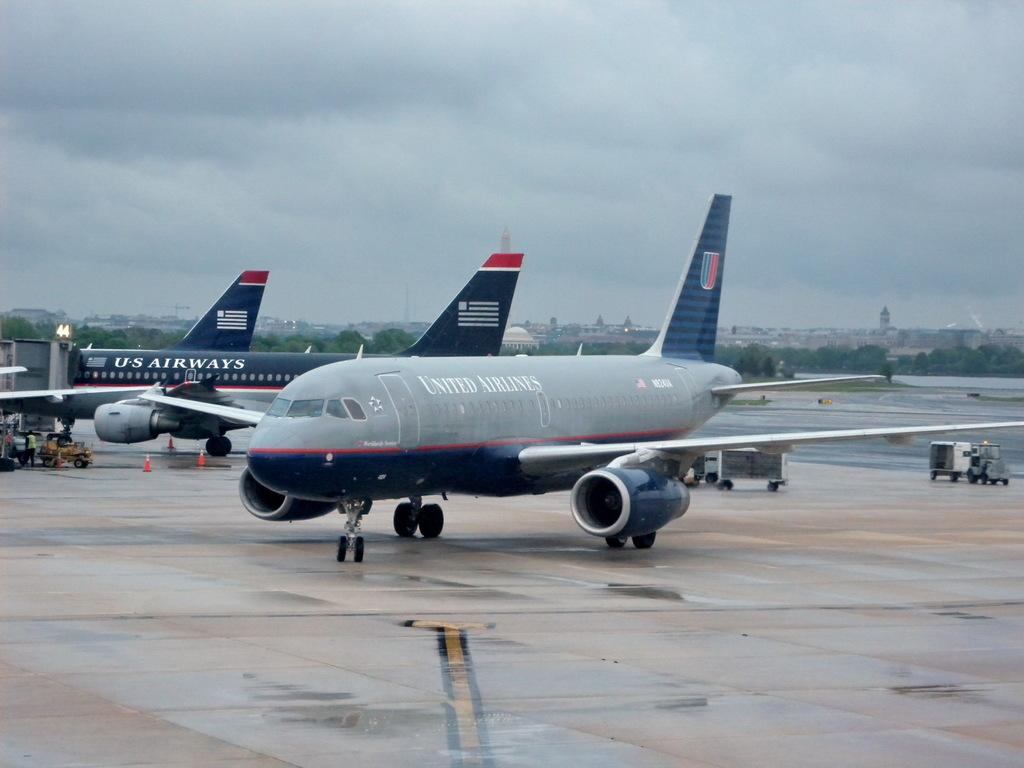<image>
Share a concise interpretation of the image provided. United Airlines Jet is parked on a cloudy rainy day. 